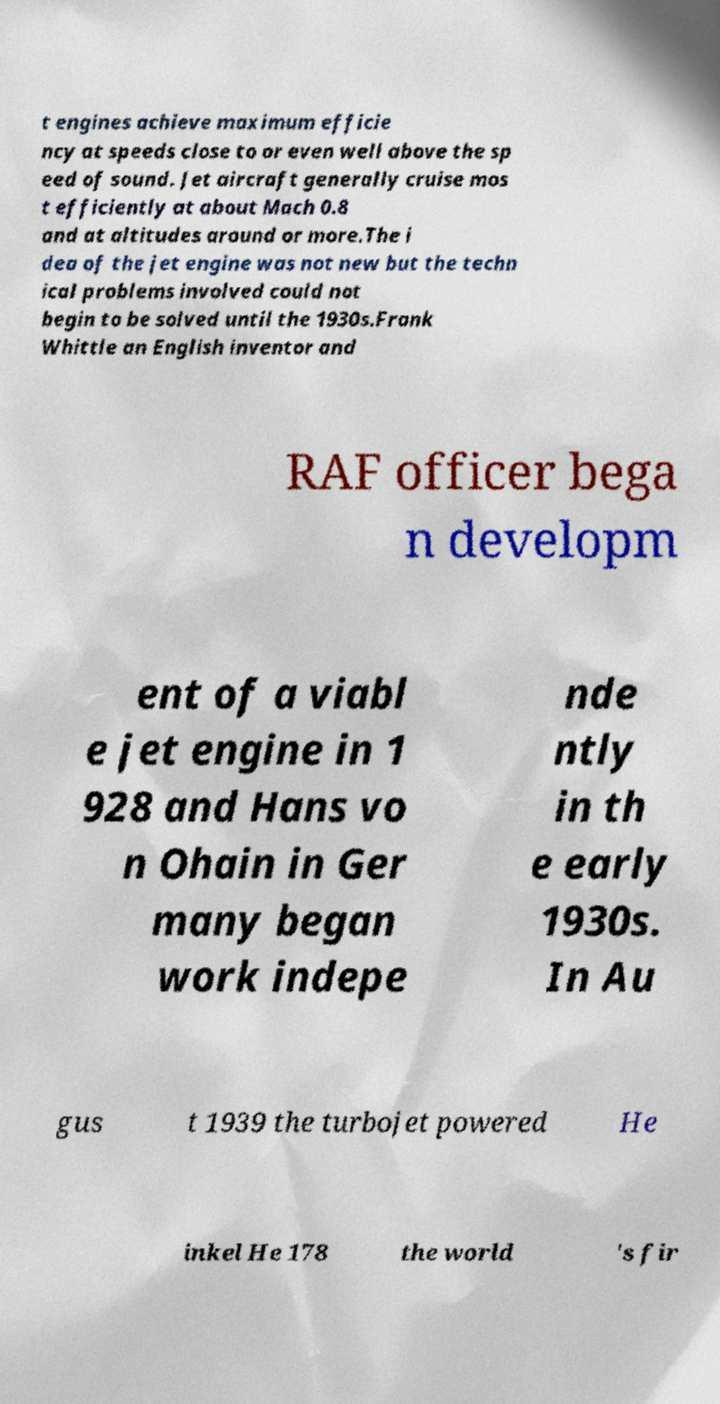For documentation purposes, I need the text within this image transcribed. Could you provide that? t engines achieve maximum efficie ncy at speeds close to or even well above the sp eed of sound. Jet aircraft generally cruise mos t efficiently at about Mach 0.8 and at altitudes around or more.The i dea of the jet engine was not new but the techn ical problems involved could not begin to be solved until the 1930s.Frank Whittle an English inventor and RAF officer bega n developm ent of a viabl e jet engine in 1 928 and Hans vo n Ohain in Ger many began work indepe nde ntly in th e early 1930s. In Au gus t 1939 the turbojet powered He inkel He 178 the world 's fir 